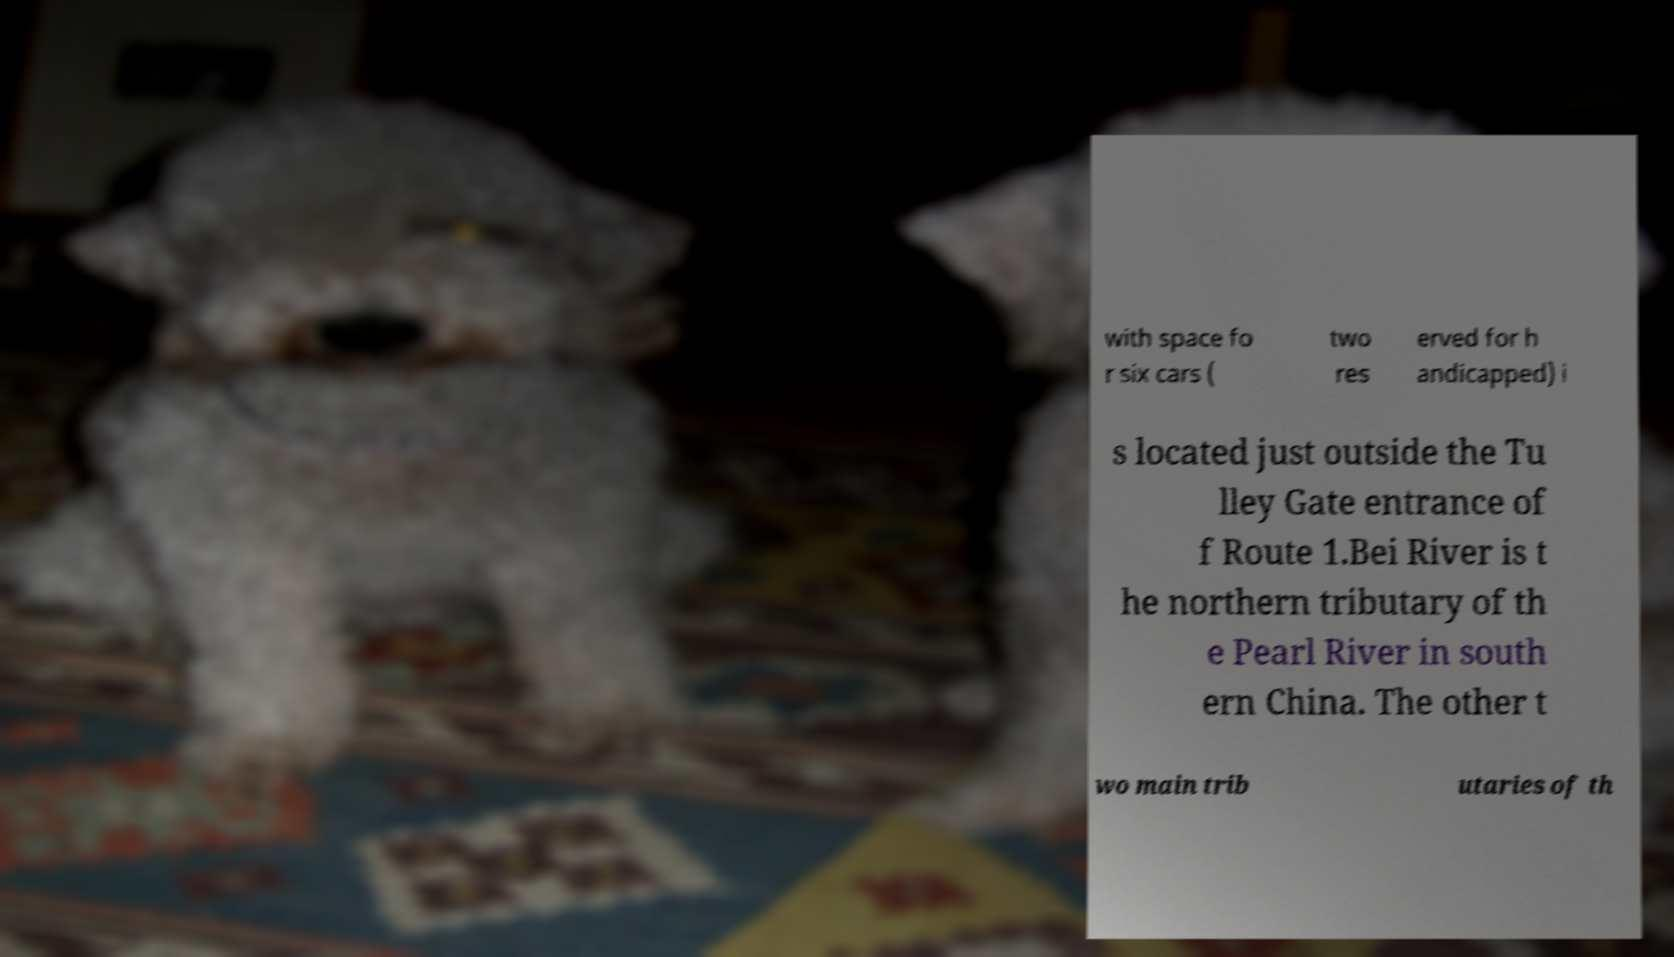Can you accurately transcribe the text from the provided image for me? with space fo r six cars ( two res erved for h andicapped) i s located just outside the Tu lley Gate entrance of f Route 1.Bei River is t he northern tributary of th e Pearl River in south ern China. The other t wo main trib utaries of th 